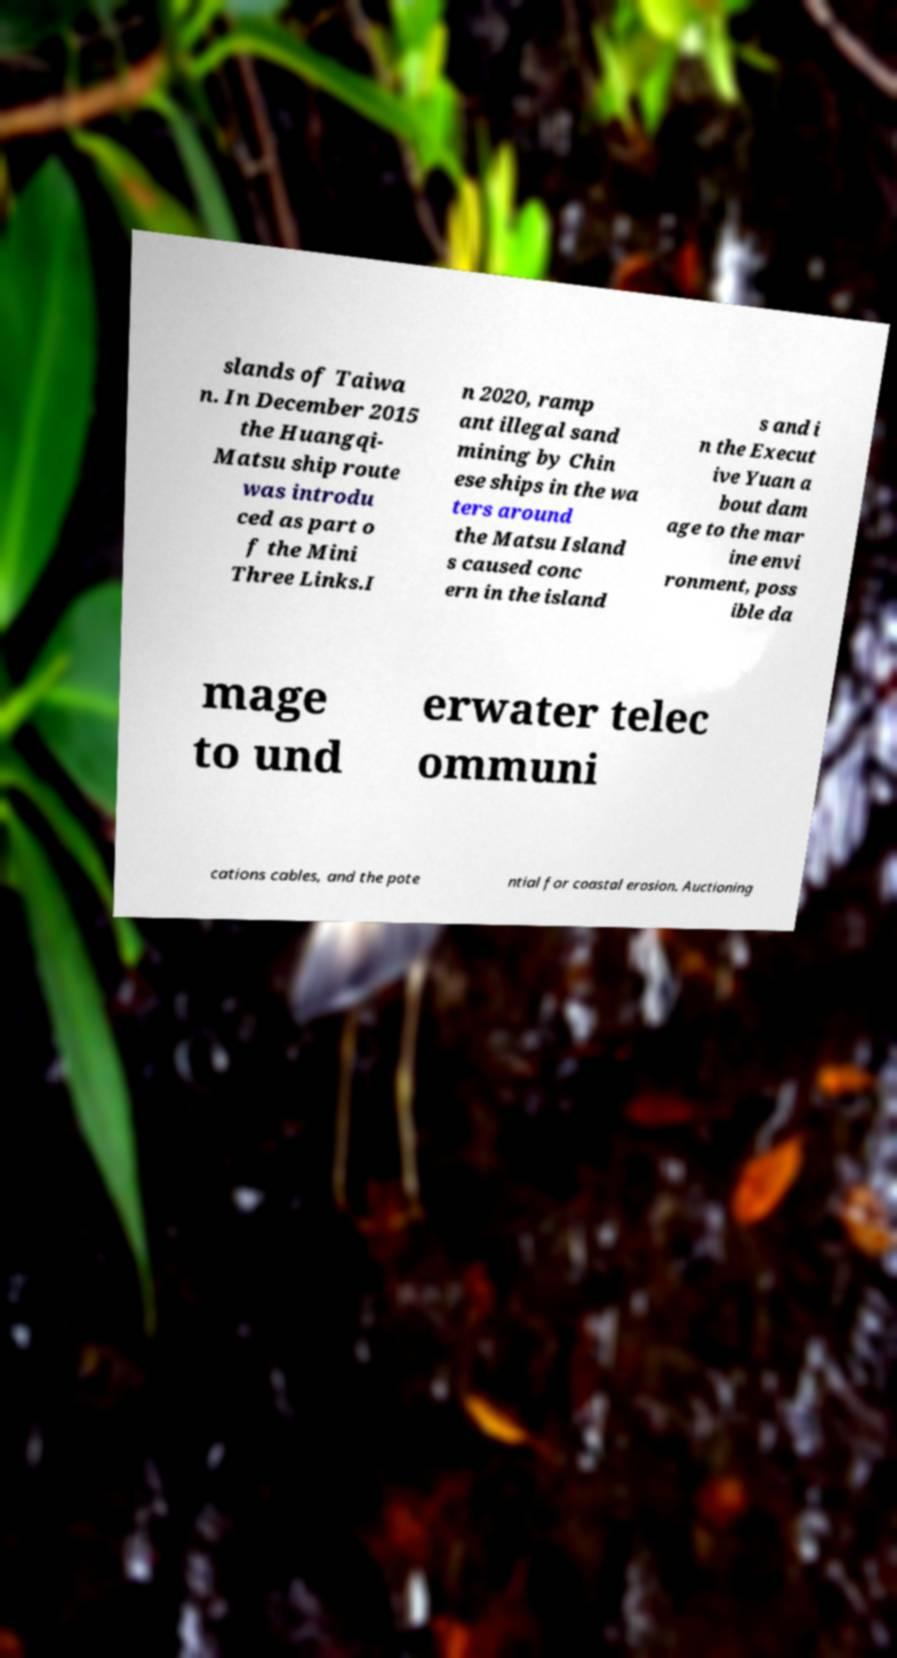Could you assist in decoding the text presented in this image and type it out clearly? slands of Taiwa n. In December 2015 the Huangqi- Matsu ship route was introdu ced as part o f the Mini Three Links.I n 2020, ramp ant illegal sand mining by Chin ese ships in the wa ters around the Matsu Island s caused conc ern in the island s and i n the Execut ive Yuan a bout dam age to the mar ine envi ronment, poss ible da mage to und erwater telec ommuni cations cables, and the pote ntial for coastal erosion. Auctioning 